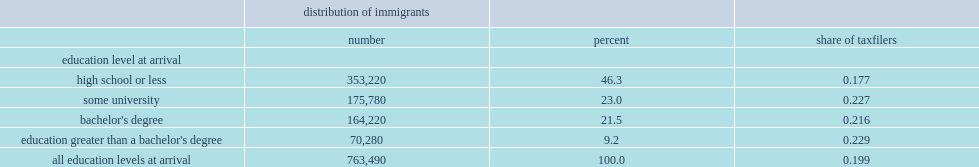What the point of those entering with bachelor's degrees were self-employed in 2010? 0.227. What the percent of those with a high-school education or less were self-employed in 2010? 0.177. 